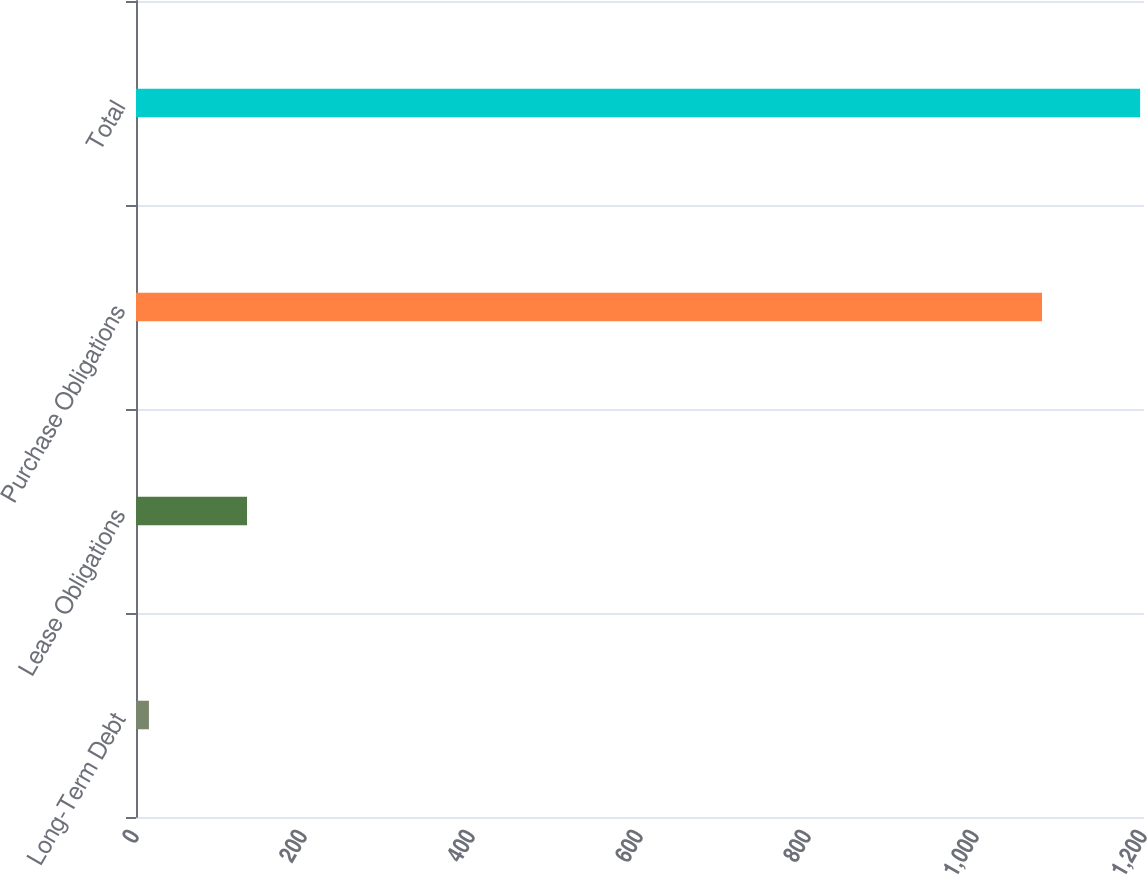<chart> <loc_0><loc_0><loc_500><loc_500><bar_chart><fcel>Long-Term Debt<fcel>Lease Obligations<fcel>Purchase Obligations<fcel>Total<nl><fcel>15.4<fcel>132.18<fcel>1078.6<fcel>1195.38<nl></chart> 